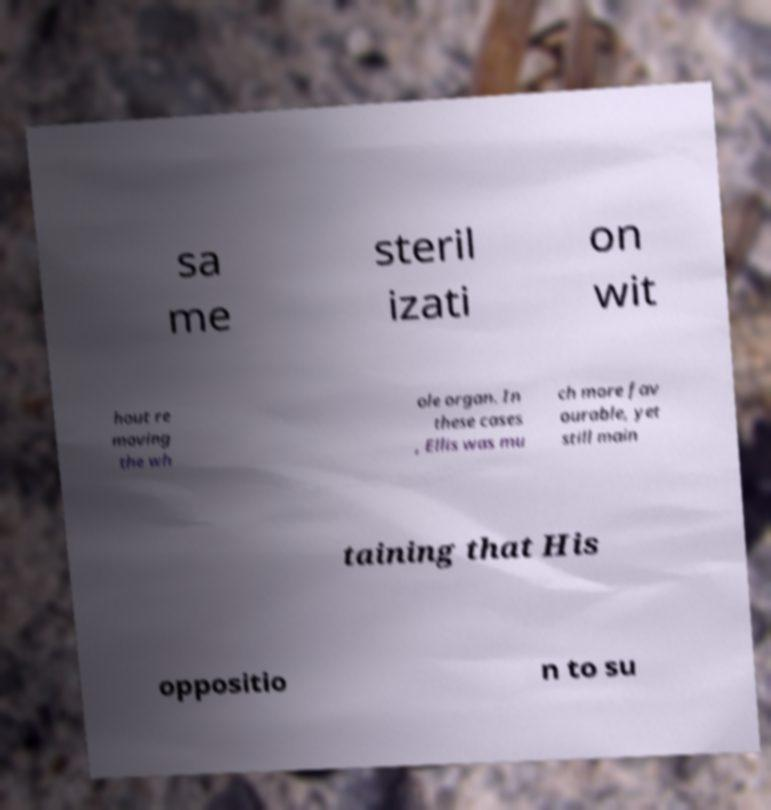Could you extract and type out the text from this image? sa me steril izati on wit hout re moving the wh ole organ. In these cases , Ellis was mu ch more fav ourable, yet still main taining that His oppositio n to su 